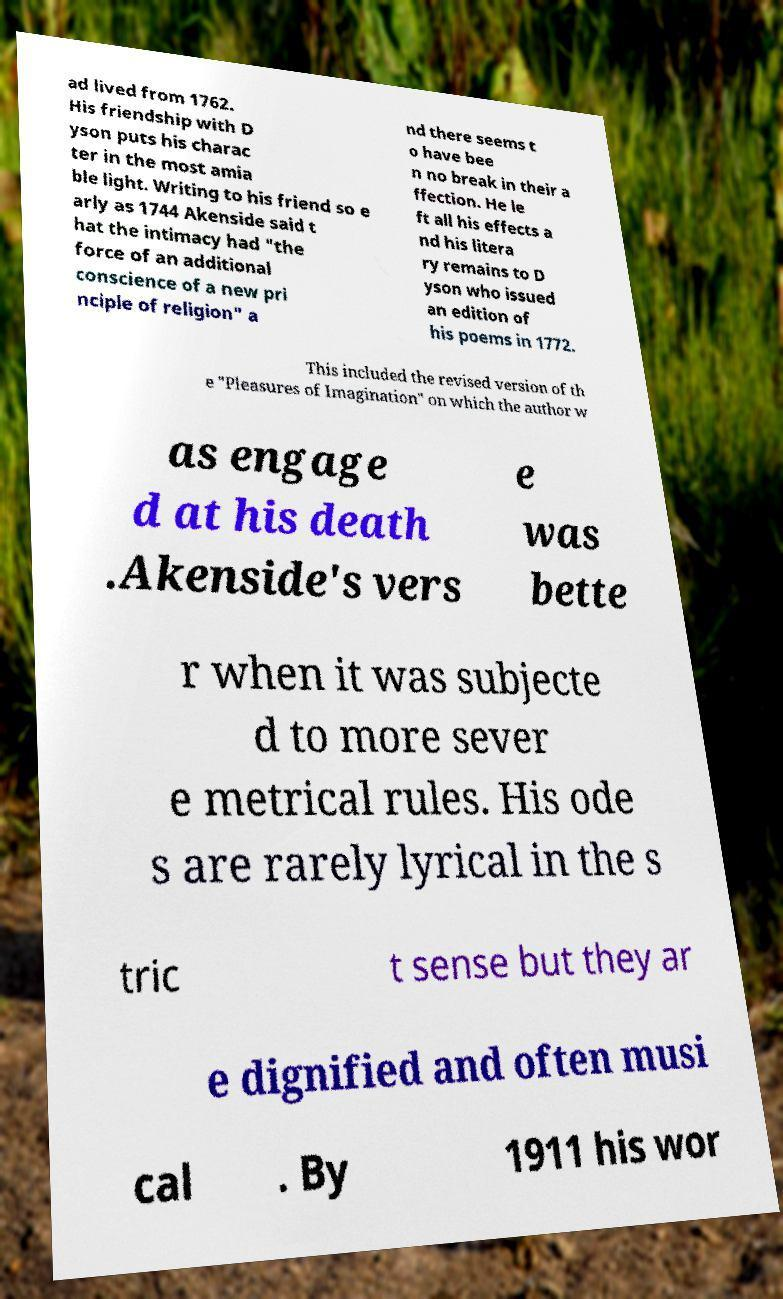Can you read and provide the text displayed in the image?This photo seems to have some interesting text. Can you extract and type it out for me? ad lived from 1762. His friendship with D yson puts his charac ter in the most amia ble light. Writing to his friend so e arly as 1744 Akenside said t hat the intimacy had "the force of an additional conscience of a new pri nciple of religion" a nd there seems t o have bee n no break in their a ffection. He le ft all his effects a nd his litera ry remains to D yson who issued an edition of his poems in 1772. This included the revised version of th e "Pleasures of Imagination" on which the author w as engage d at his death .Akenside's vers e was bette r when it was subjecte d to more sever e metrical rules. His ode s are rarely lyrical in the s tric t sense but they ar e dignified and often musi cal . By 1911 his wor 